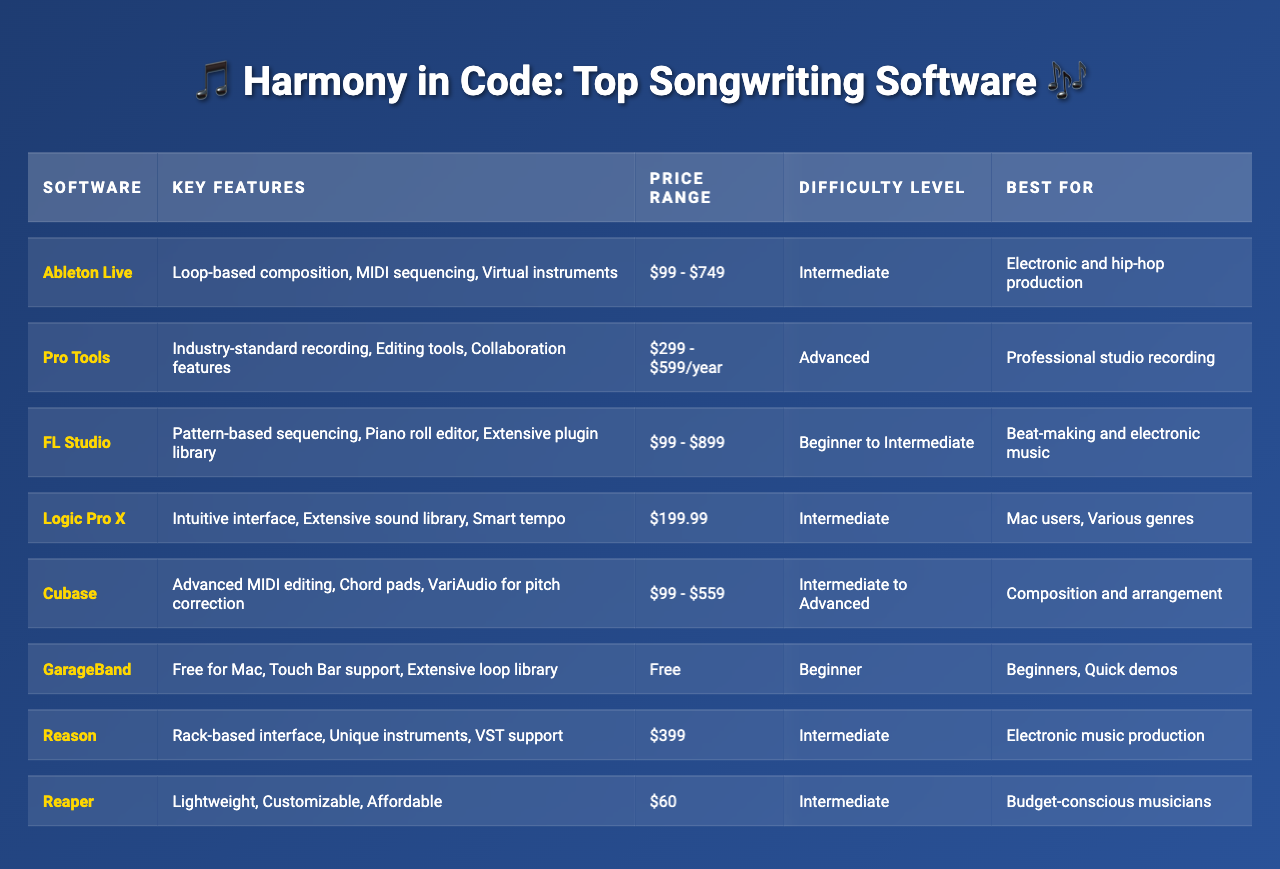What is the price range for FL Studio? The table lists the price range for FL Studio as "$99 - $899".
Answer: $99 - $899 Which software is best for beginners? The table shows that GarageBand is listed as "Best For: Beginners, Quick demos."
Answer: GarageBand What are the key features of Pro Tools? Looking at the table, the key features listed for Pro Tools are "Industry-standard recording, Editing tools, Collaboration features."
Answer: Industry-standard recording, Editing tools, Collaboration features Which software has the highest price range? The table indicates that FL Studio has a price range of "$99 - $899", while Pro Tools has a range of "$299 - $599/year". Therefore, FL Studio has the highest price range.
Answer: FL Studio Is Logic Pro X free for users? The table notes that Logic Pro X is priced at "$199.99", which means it is not free.
Answer: No Which software is best for electronic music production? The table states that both Ableton Live and Reason are recommended for "Electronic and hip-hop production" and "Electronic music production" respectively, therefore either could be an answer.
Answer: Ableton Live or Reason How many software options are categorized as beginner level? By reviewing the table, GarageBand is the only software listed as "Beginner".
Answer: 1 Which software has the same difficulty level as GarageBand? The table shows that both GarageBand and FL Studio are categorized as "Beginner to Intermediate." Both share similar starting points for difficulty.
Answer: FL Studio What is the main characteristic that differentiates Pro Tools from the others? Pro Tools is unique in being described as "Industry-standard recording," indicating its professional focus versus the other options that are more varied.
Answer: Industry-standard recording How do the key features of Logic Pro X compare with those of FL Studio? Logic Pro X features "Intuitive interface, Extensive sound library, Smart tempo," while FL Studio has "Pattern-based sequencing, Piano roll editor, Extensive plugin library." The former focuses on user-friendliness while FL Studio emphasizes sequencing tools.
Answer: Logic Pro X focuses on simplicity, FL Studio emphasizes sequencing 